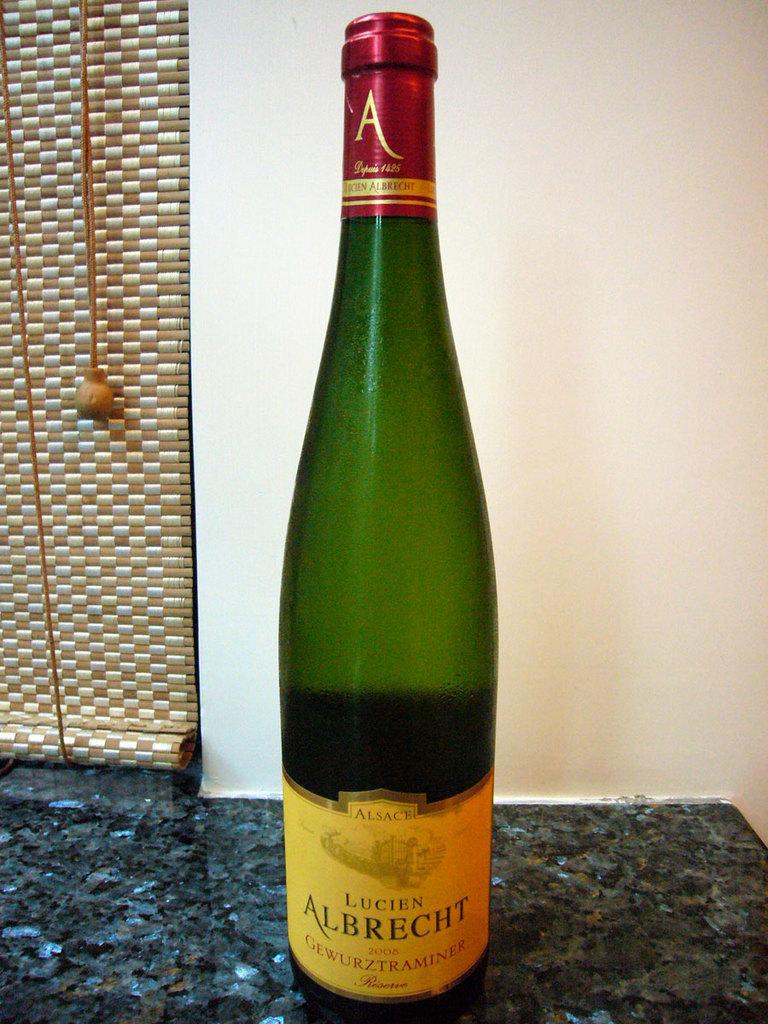What brand is this?
Ensure brevity in your answer.  Lucien albrecht. What year was this bottled>?
Provide a succinct answer. 2008. 